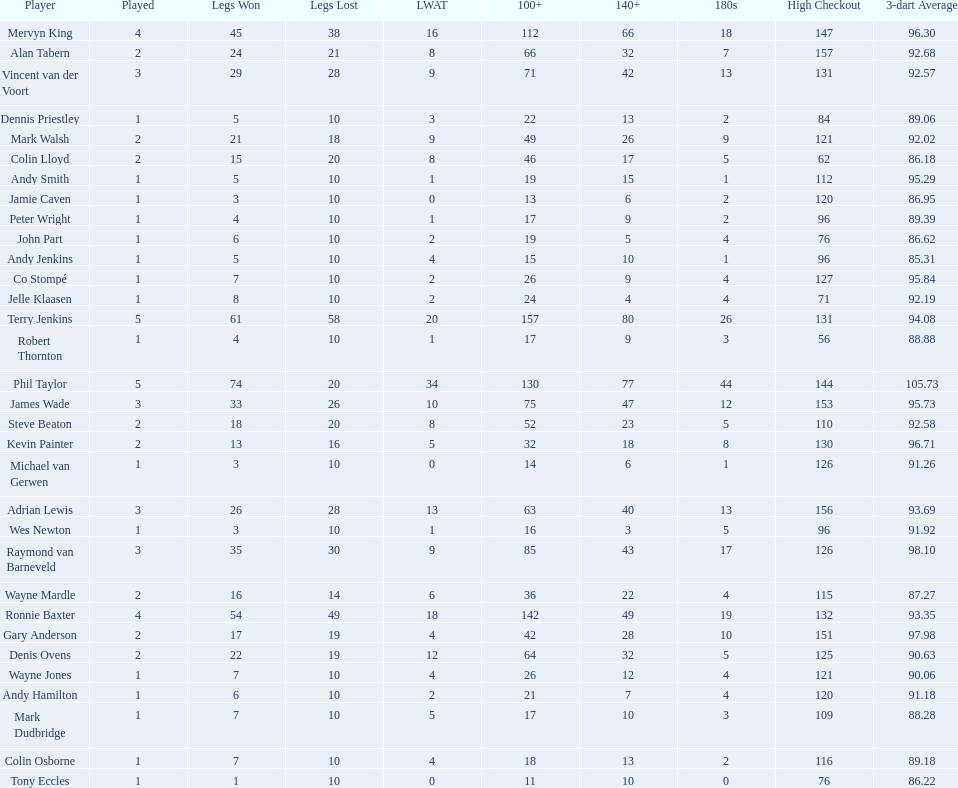List each of the players with a high checkout of 131. Terry Jenkins, Vincent van der Voort. 